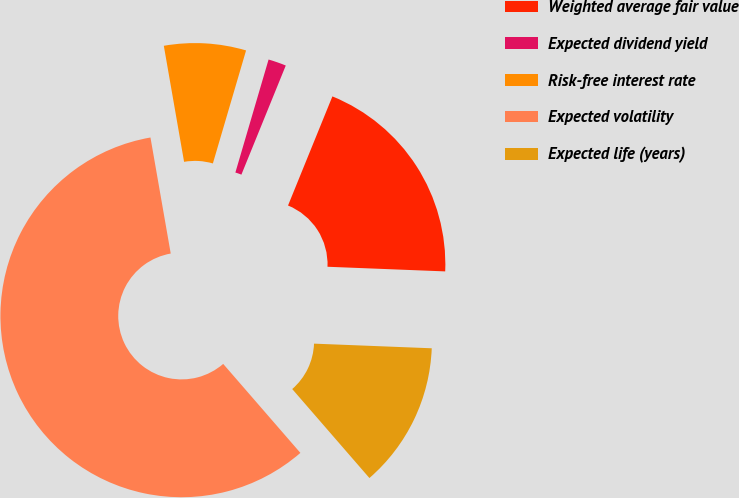Convert chart to OTSL. <chart><loc_0><loc_0><loc_500><loc_500><pie_chart><fcel>Weighted average fair value<fcel>Expected dividend yield<fcel>Risk-free interest rate<fcel>Expected volatility<fcel>Expected life (years)<nl><fcel>19.48%<fcel>1.6%<fcel>7.3%<fcel>58.62%<fcel>13.0%<nl></chart> 